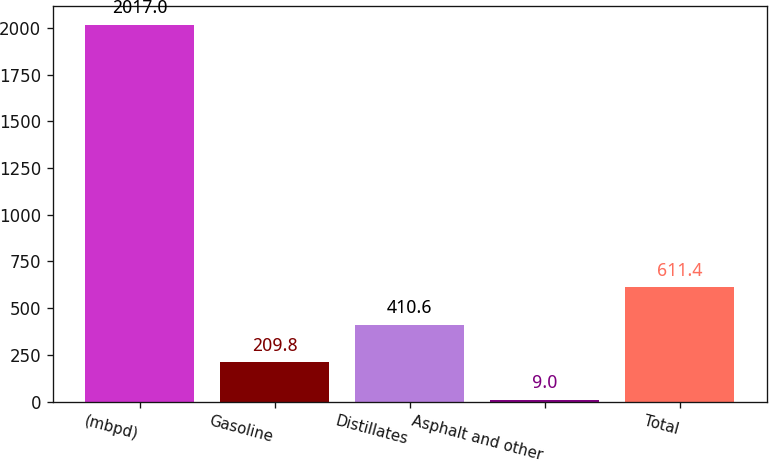<chart> <loc_0><loc_0><loc_500><loc_500><bar_chart><fcel>(mbpd)<fcel>Gasoline<fcel>Distillates<fcel>Asphalt and other<fcel>Total<nl><fcel>2017<fcel>209.8<fcel>410.6<fcel>9<fcel>611.4<nl></chart> 